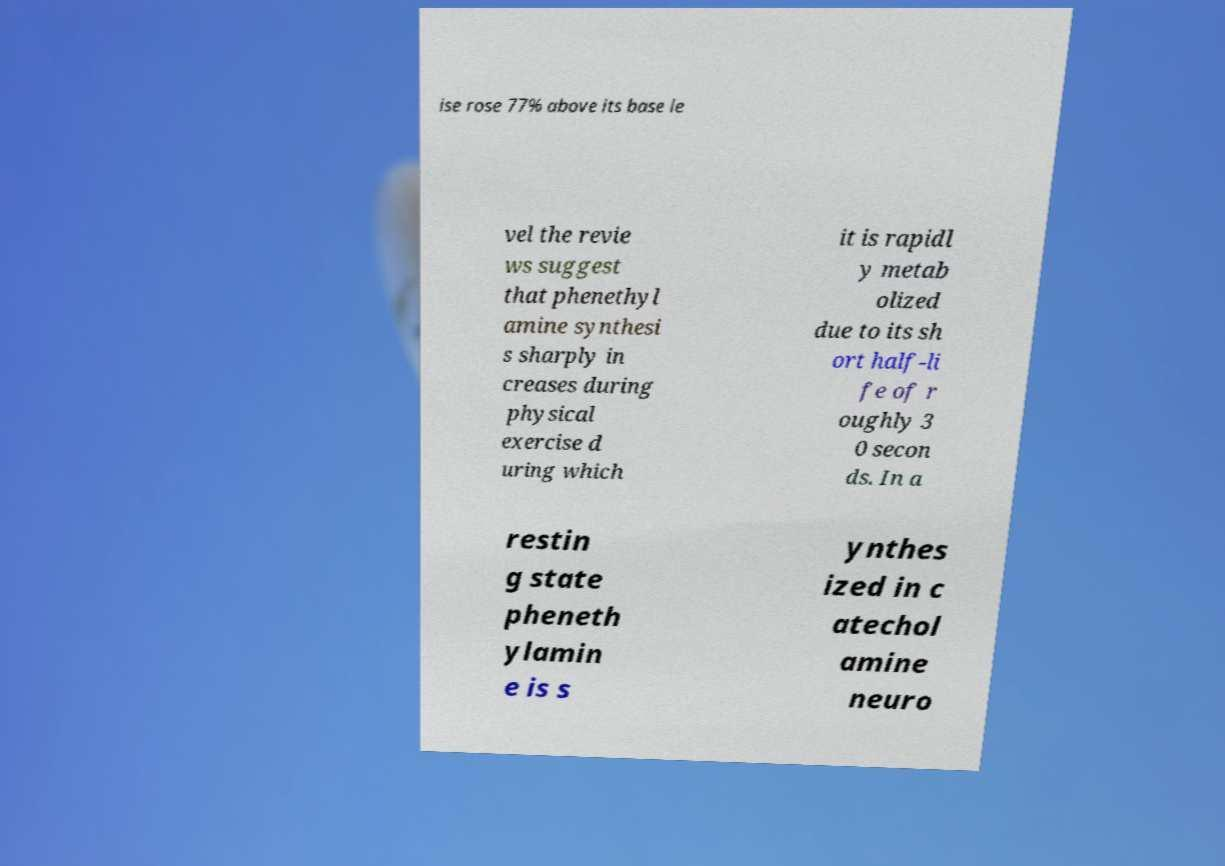Could you assist in decoding the text presented in this image and type it out clearly? ise rose 77% above its base le vel the revie ws suggest that phenethyl amine synthesi s sharply in creases during physical exercise d uring which it is rapidl y metab olized due to its sh ort half-li fe of r oughly 3 0 secon ds. In a restin g state pheneth ylamin e is s ynthes ized in c atechol amine neuro 